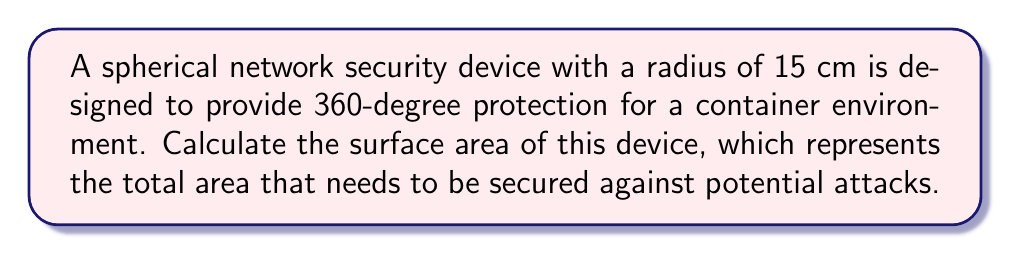Teach me how to tackle this problem. To solve this problem, we'll follow these steps:

1) The formula for the surface area of a sphere is:
   
   $$ A = 4\pi r^2 $$
   
   where $A$ is the surface area and $r$ is the radius.

2) We're given that the radius is 15 cm. Let's substitute this into our formula:
   
   $$ A = 4\pi (15\text{ cm})^2 $$

3) Simplify the squared term:
   
   $$ A = 4\pi (225\text{ cm}^2) $$

4) Multiply:
   
   $$ A = 900\pi\text{ cm}^2 $$

5) If we need a decimal approximation, we can multiply by $\pi \approx 3.14159$:
   
   $$ A \approx 2827.43\text{ cm}^2 $$

Therefore, the surface area of the spherical network security device is $900\pi\text{ cm}^2$ or approximately $2827.43\text{ cm}^2$.
Answer: $900\pi\text{ cm}^2$ 